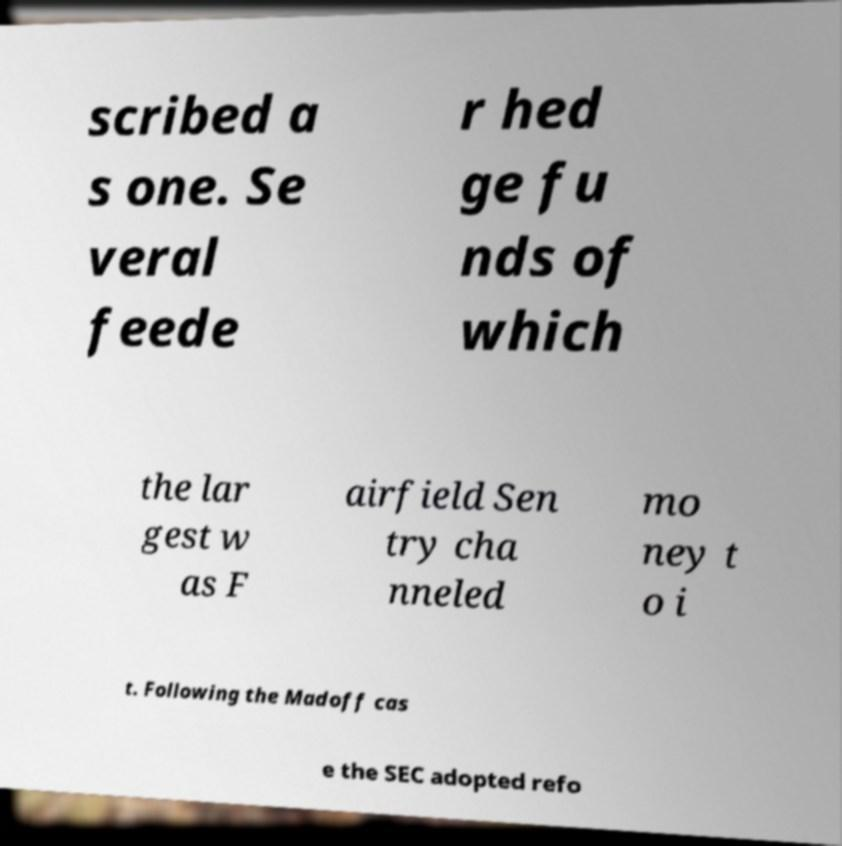Please read and relay the text visible in this image. What does it say? scribed a s one. Se veral feede r hed ge fu nds of which the lar gest w as F airfield Sen try cha nneled mo ney t o i t. Following the Madoff cas e the SEC adopted refo 